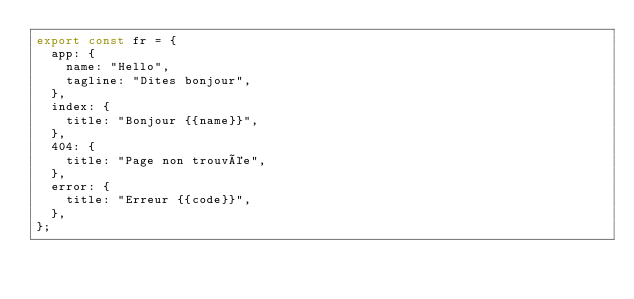<code> <loc_0><loc_0><loc_500><loc_500><_TypeScript_>export const fr = {
  app: {
    name: "Hello",
    tagline: "Dites bonjour",
  },
  index: {
    title: "Bonjour {{name}}",
  },
  404: {
    title: "Page non trouvée",
  },
  error: {
    title: "Erreur {{code}}",
  },
};
</code> 